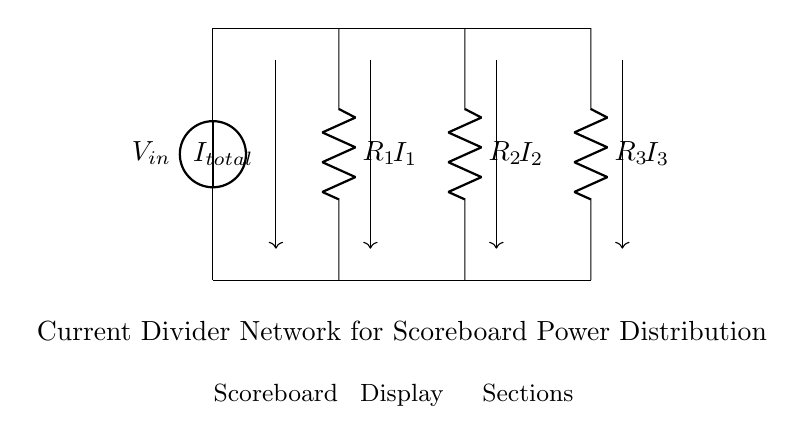What is the total current entering the circuit? The total current entering the circuit is represented as I total, indicated by the arrow pointing downwards to the bottom node from the top across the voltage source.
Answer: I total What components are in parallel in this circuit? The resistors R1, R2, and R3 are in parallel, as they share the same voltage across them from the common input voltage.
Answer: R1, R2, R3 How many resistors are present in this current divider? There are three resistors shown in the diagram (R1, R2, R3), which form the current divider network for distributing power to the scoreboard display.
Answer: 3 Which resistor would have the highest current flowing through it? The highest current would flow through the resistor with the smallest resistance value, based on Ohm's Law and the current divider principle; the specific resistor cannot be determined from the diagram alone without resistance values.
Answer: The smallest resistance If the total input voltage is 12 volts, what is the voltage across each resistor? The voltage across each resistor is the same as the input voltage (12 volts) since they are in parallel, which implies each resistor experiences the entire input voltage.
Answer: 12 volts What role does this current divider play in the scoreboard system? The current divider distributes the input current among the parallel resistors to ensure that each section of the scoreboard receives an appropriate amount of current for its function.
Answer: Power distribution 